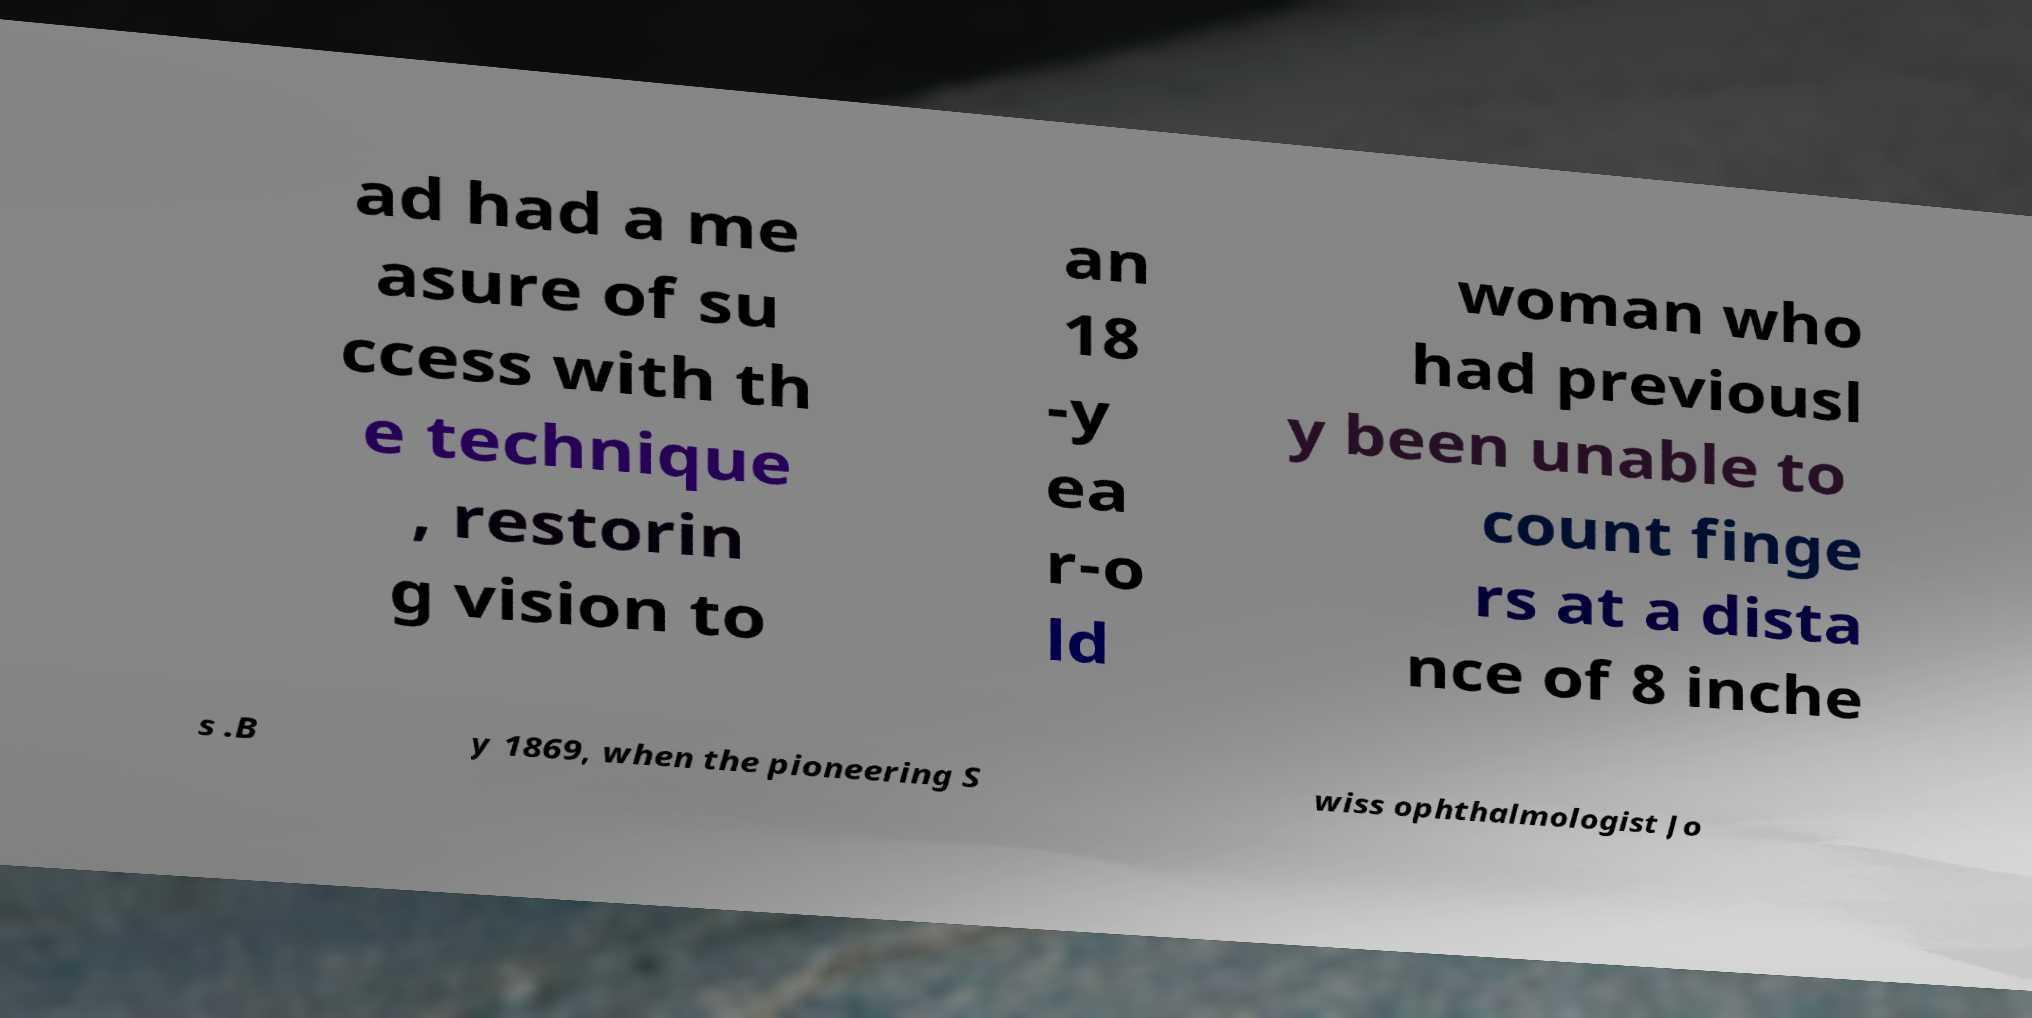For documentation purposes, I need the text within this image transcribed. Could you provide that? ad had a me asure of su ccess with th e technique , restorin g vision to an 18 -y ea r-o ld woman who had previousl y been unable to count finge rs at a dista nce of 8 inche s .B y 1869, when the pioneering S wiss ophthalmologist Jo 